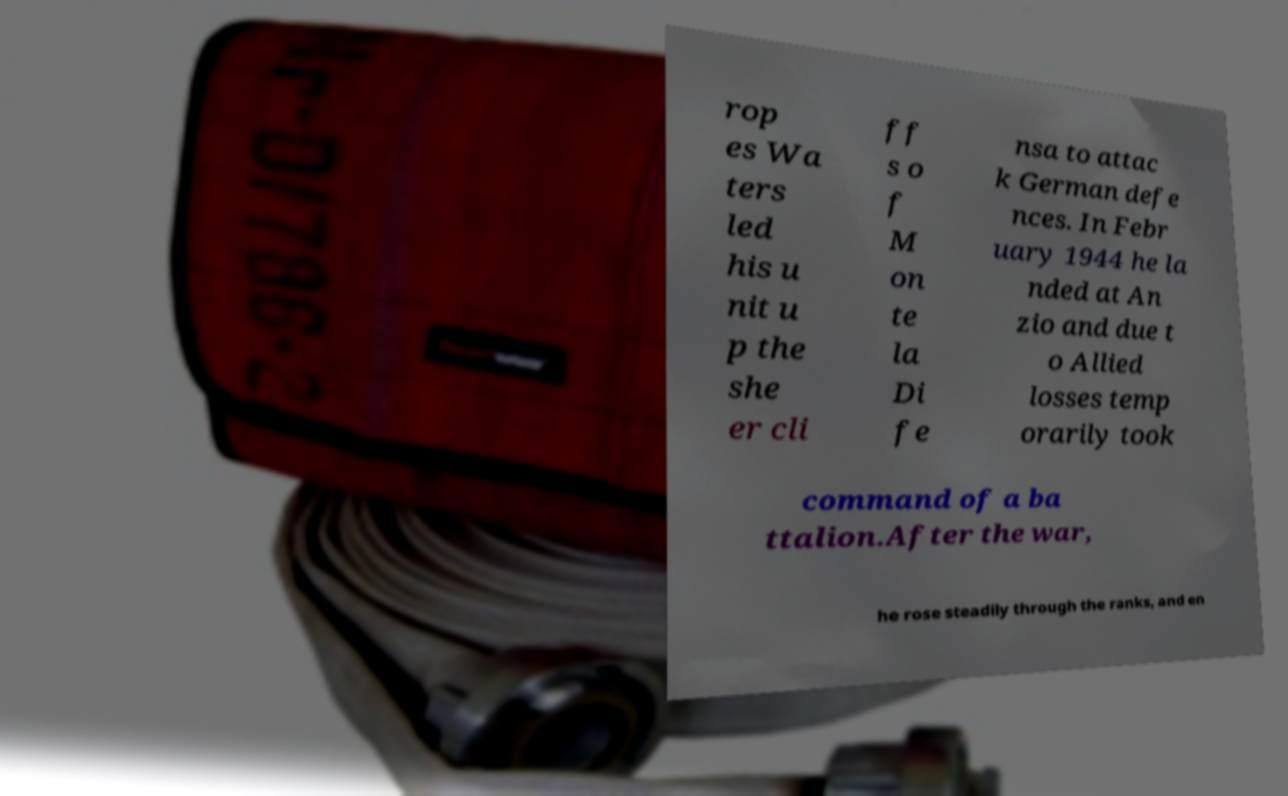Could you assist in decoding the text presented in this image and type it out clearly? rop es Wa ters led his u nit u p the she er cli ff s o f M on te la Di fe nsa to attac k German defe nces. In Febr uary 1944 he la nded at An zio and due t o Allied losses temp orarily took command of a ba ttalion.After the war, he rose steadily through the ranks, and en 